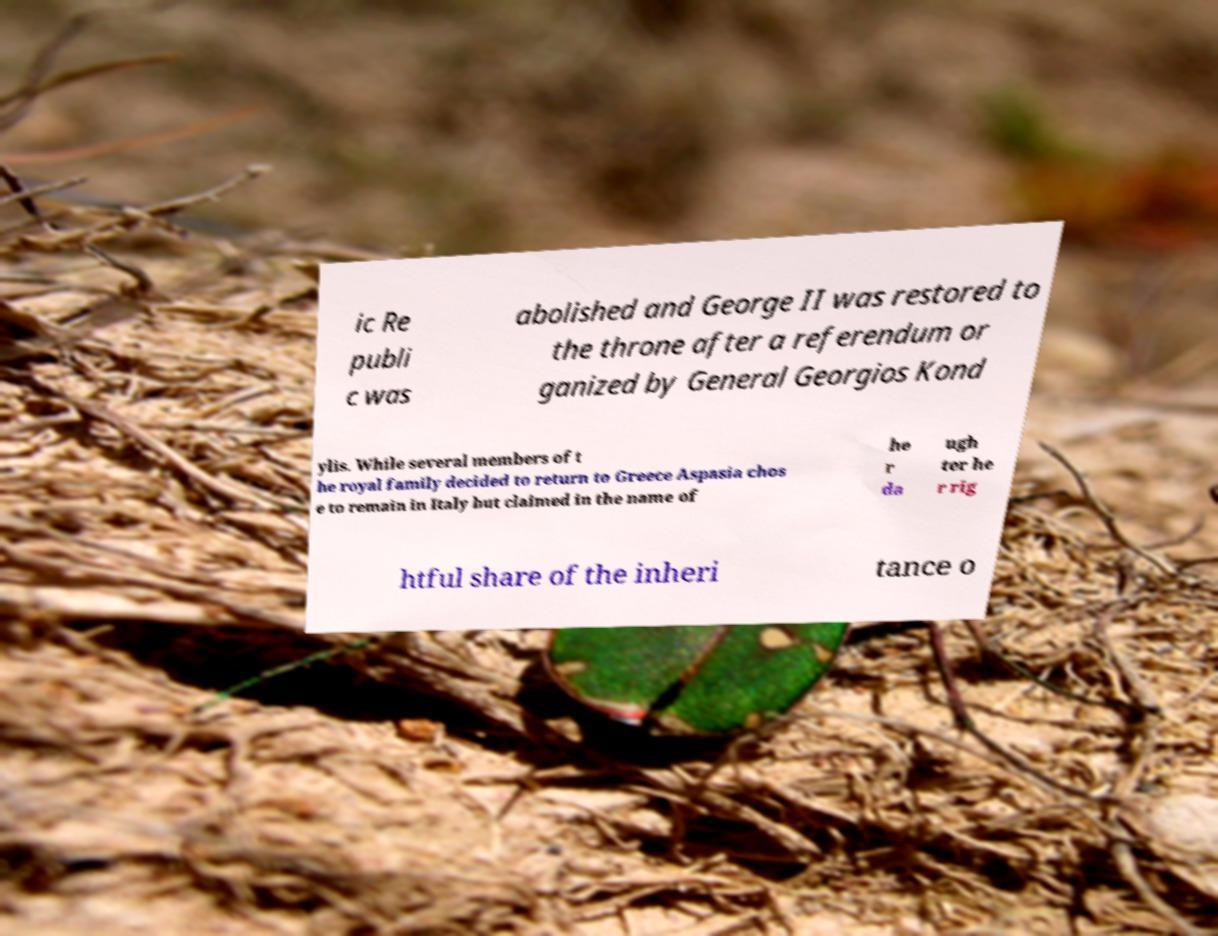Please identify and transcribe the text found in this image. ic Re publi c was abolished and George II was restored to the throne after a referendum or ganized by General Georgios Kond ylis. While several members of t he royal family decided to return to Greece Aspasia chos e to remain in Italy but claimed in the name of he r da ugh ter he r rig htful share of the inheri tance o 